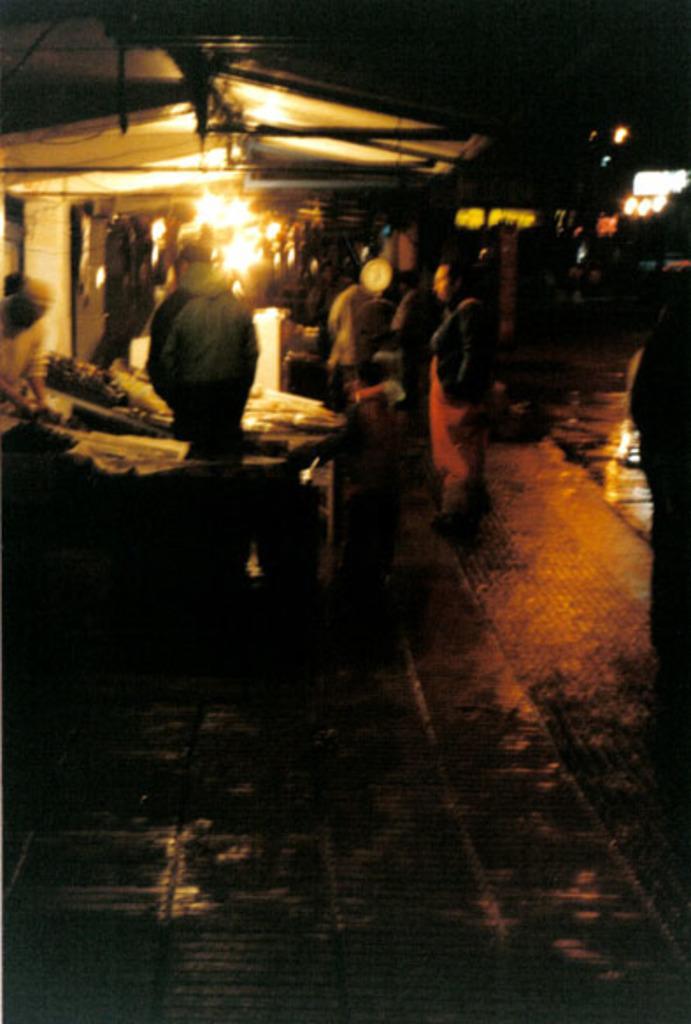How would you summarize this image in a sentence or two? In the foreground of this image, it seems like a market where people are standing on the side path in the dark. We can also see few lights. 